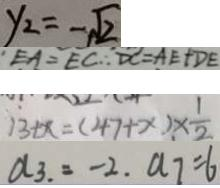Convert formula to latex. <formula><loc_0><loc_0><loc_500><loc_500>y _ { 2 } = - \sqrt { 2 } 
 E A = E C \therefore D C = A E + D E 
 1 3 + x = ( 4 7 + x ) \times \frac { 1 } { 2 } 
 a _ { 3 } = - 2 . a _ { 7 } = 6</formula> 